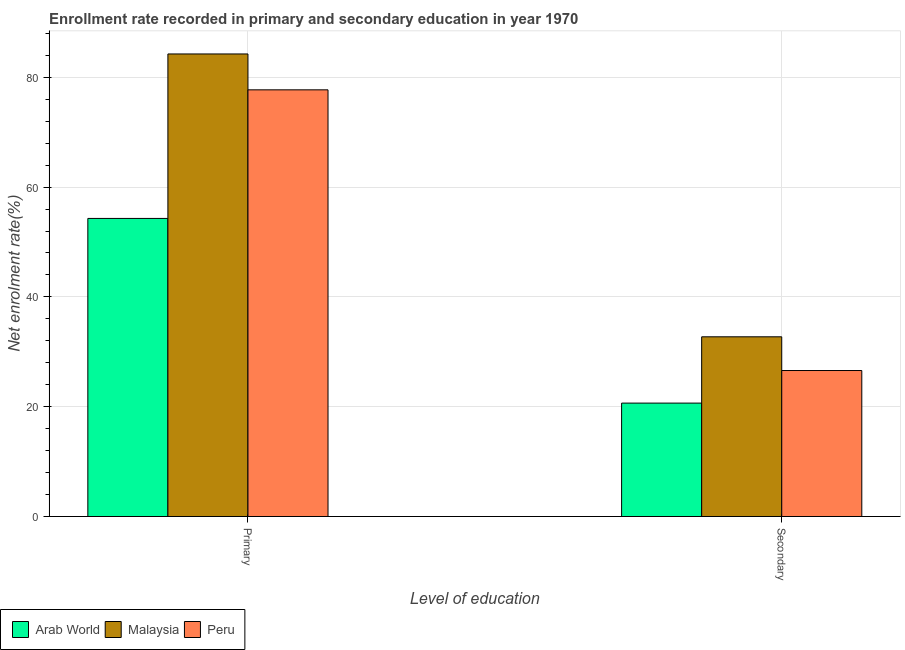How many groups of bars are there?
Make the answer very short. 2. Are the number of bars per tick equal to the number of legend labels?
Give a very brief answer. Yes. Are the number of bars on each tick of the X-axis equal?
Your answer should be compact. Yes. How many bars are there on the 2nd tick from the right?
Provide a succinct answer. 3. What is the label of the 1st group of bars from the left?
Give a very brief answer. Primary. What is the enrollment rate in primary education in Peru?
Offer a very short reply. 77.71. Across all countries, what is the maximum enrollment rate in secondary education?
Give a very brief answer. 32.73. Across all countries, what is the minimum enrollment rate in primary education?
Make the answer very short. 54.29. In which country was the enrollment rate in secondary education maximum?
Your response must be concise. Malaysia. In which country was the enrollment rate in secondary education minimum?
Offer a terse response. Arab World. What is the total enrollment rate in secondary education in the graph?
Make the answer very short. 79.98. What is the difference between the enrollment rate in secondary education in Malaysia and that in Peru?
Ensure brevity in your answer.  6.14. What is the difference between the enrollment rate in primary education in Peru and the enrollment rate in secondary education in Malaysia?
Your answer should be compact. 44.98. What is the average enrollment rate in secondary education per country?
Your answer should be compact. 26.66. What is the difference between the enrollment rate in secondary education and enrollment rate in primary education in Arab World?
Offer a terse response. -33.63. What is the ratio of the enrollment rate in primary education in Malaysia to that in Peru?
Your answer should be very brief. 1.08. Is the enrollment rate in secondary education in Peru less than that in Arab World?
Give a very brief answer. No. In how many countries, is the enrollment rate in secondary education greater than the average enrollment rate in secondary education taken over all countries?
Make the answer very short. 1. What does the 3rd bar from the right in Primary represents?
Your answer should be compact. Arab World. How many bars are there?
Provide a succinct answer. 6. How many countries are there in the graph?
Provide a short and direct response. 3. What is the difference between two consecutive major ticks on the Y-axis?
Your answer should be very brief. 20. Does the graph contain grids?
Make the answer very short. Yes. Where does the legend appear in the graph?
Give a very brief answer. Bottom left. How many legend labels are there?
Offer a very short reply. 3. How are the legend labels stacked?
Offer a very short reply. Horizontal. What is the title of the graph?
Keep it short and to the point. Enrollment rate recorded in primary and secondary education in year 1970. Does "Ethiopia" appear as one of the legend labels in the graph?
Make the answer very short. No. What is the label or title of the X-axis?
Keep it short and to the point. Level of education. What is the label or title of the Y-axis?
Offer a very short reply. Net enrolment rate(%). What is the Net enrolment rate(%) of Arab World in Primary?
Offer a terse response. 54.29. What is the Net enrolment rate(%) of Malaysia in Primary?
Offer a terse response. 84.25. What is the Net enrolment rate(%) in Peru in Primary?
Make the answer very short. 77.71. What is the Net enrolment rate(%) in Arab World in Secondary?
Provide a short and direct response. 20.66. What is the Net enrolment rate(%) of Malaysia in Secondary?
Offer a very short reply. 32.73. What is the Net enrolment rate(%) in Peru in Secondary?
Ensure brevity in your answer.  26.59. Across all Level of education, what is the maximum Net enrolment rate(%) in Arab World?
Provide a short and direct response. 54.29. Across all Level of education, what is the maximum Net enrolment rate(%) of Malaysia?
Provide a short and direct response. 84.25. Across all Level of education, what is the maximum Net enrolment rate(%) of Peru?
Keep it short and to the point. 77.71. Across all Level of education, what is the minimum Net enrolment rate(%) of Arab World?
Ensure brevity in your answer.  20.66. Across all Level of education, what is the minimum Net enrolment rate(%) in Malaysia?
Keep it short and to the point. 32.73. Across all Level of education, what is the minimum Net enrolment rate(%) in Peru?
Offer a terse response. 26.59. What is the total Net enrolment rate(%) of Arab World in the graph?
Your answer should be compact. 74.95. What is the total Net enrolment rate(%) of Malaysia in the graph?
Your response must be concise. 116.98. What is the total Net enrolment rate(%) in Peru in the graph?
Offer a very short reply. 104.3. What is the difference between the Net enrolment rate(%) in Arab World in Primary and that in Secondary?
Your response must be concise. 33.63. What is the difference between the Net enrolment rate(%) in Malaysia in Primary and that in Secondary?
Ensure brevity in your answer.  51.51. What is the difference between the Net enrolment rate(%) in Peru in Primary and that in Secondary?
Offer a terse response. 51.12. What is the difference between the Net enrolment rate(%) in Arab World in Primary and the Net enrolment rate(%) in Malaysia in Secondary?
Your response must be concise. 21.56. What is the difference between the Net enrolment rate(%) in Arab World in Primary and the Net enrolment rate(%) in Peru in Secondary?
Provide a short and direct response. 27.7. What is the difference between the Net enrolment rate(%) of Malaysia in Primary and the Net enrolment rate(%) of Peru in Secondary?
Your answer should be very brief. 57.65. What is the average Net enrolment rate(%) in Arab World per Level of education?
Provide a short and direct response. 37.47. What is the average Net enrolment rate(%) of Malaysia per Level of education?
Keep it short and to the point. 58.49. What is the average Net enrolment rate(%) of Peru per Level of education?
Offer a very short reply. 52.15. What is the difference between the Net enrolment rate(%) of Arab World and Net enrolment rate(%) of Malaysia in Primary?
Offer a terse response. -29.96. What is the difference between the Net enrolment rate(%) in Arab World and Net enrolment rate(%) in Peru in Primary?
Keep it short and to the point. -23.42. What is the difference between the Net enrolment rate(%) in Malaysia and Net enrolment rate(%) in Peru in Primary?
Your answer should be compact. 6.53. What is the difference between the Net enrolment rate(%) of Arab World and Net enrolment rate(%) of Malaysia in Secondary?
Make the answer very short. -12.07. What is the difference between the Net enrolment rate(%) in Arab World and Net enrolment rate(%) in Peru in Secondary?
Offer a terse response. -5.93. What is the difference between the Net enrolment rate(%) of Malaysia and Net enrolment rate(%) of Peru in Secondary?
Ensure brevity in your answer.  6.14. What is the ratio of the Net enrolment rate(%) of Arab World in Primary to that in Secondary?
Give a very brief answer. 2.63. What is the ratio of the Net enrolment rate(%) in Malaysia in Primary to that in Secondary?
Your response must be concise. 2.57. What is the ratio of the Net enrolment rate(%) of Peru in Primary to that in Secondary?
Give a very brief answer. 2.92. What is the difference between the highest and the second highest Net enrolment rate(%) in Arab World?
Ensure brevity in your answer.  33.63. What is the difference between the highest and the second highest Net enrolment rate(%) in Malaysia?
Your answer should be compact. 51.51. What is the difference between the highest and the second highest Net enrolment rate(%) of Peru?
Your answer should be compact. 51.12. What is the difference between the highest and the lowest Net enrolment rate(%) of Arab World?
Your response must be concise. 33.63. What is the difference between the highest and the lowest Net enrolment rate(%) in Malaysia?
Offer a very short reply. 51.51. What is the difference between the highest and the lowest Net enrolment rate(%) of Peru?
Ensure brevity in your answer.  51.12. 